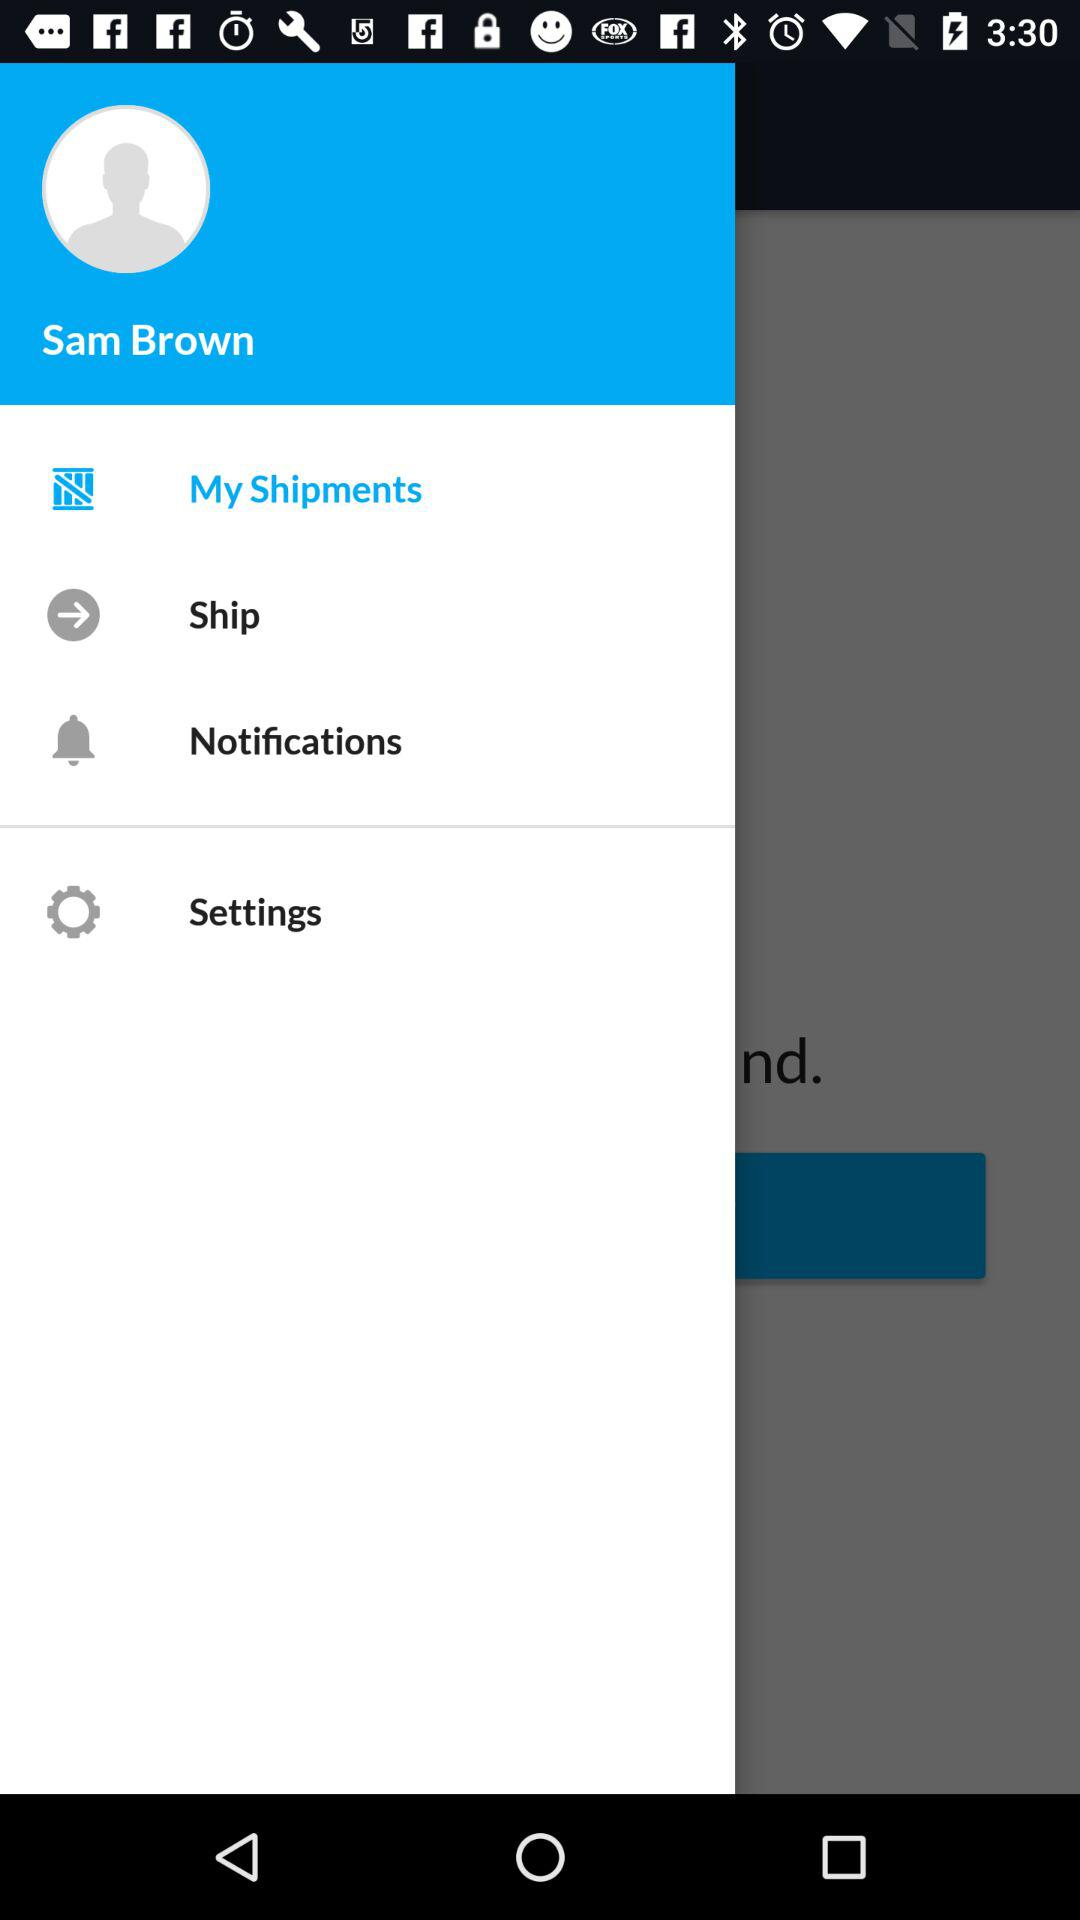Which item is selected? The selected item is "My Shipments". 